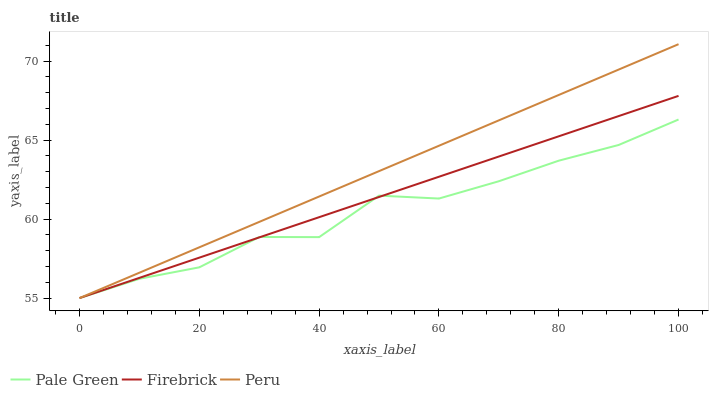Does Pale Green have the minimum area under the curve?
Answer yes or no. Yes. Does Peru have the maximum area under the curve?
Answer yes or no. Yes. Does Peru have the minimum area under the curve?
Answer yes or no. No. Does Pale Green have the maximum area under the curve?
Answer yes or no. No. Is Firebrick the smoothest?
Answer yes or no. Yes. Is Pale Green the roughest?
Answer yes or no. Yes. Is Peru the smoothest?
Answer yes or no. No. Is Peru the roughest?
Answer yes or no. No. Does Firebrick have the lowest value?
Answer yes or no. Yes. Does Peru have the highest value?
Answer yes or no. Yes. Does Pale Green have the highest value?
Answer yes or no. No. Does Peru intersect Firebrick?
Answer yes or no. Yes. Is Peru less than Firebrick?
Answer yes or no. No. Is Peru greater than Firebrick?
Answer yes or no. No. 